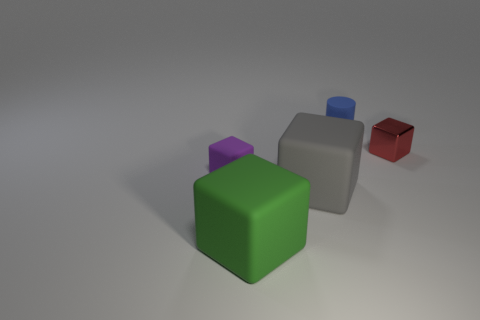Imagine this is a scene from a game, what could be the objective involving these cubes? In the context of a game, the objective could involve spatial logic and strategy. Players might be challenged to navigate a character through the cubes, rearrange them according to specific rules, or even collect them based on color or order. The staggered formation could present an additional layer of difficulty, requiring players to plan their moves to progress without obstacles. 